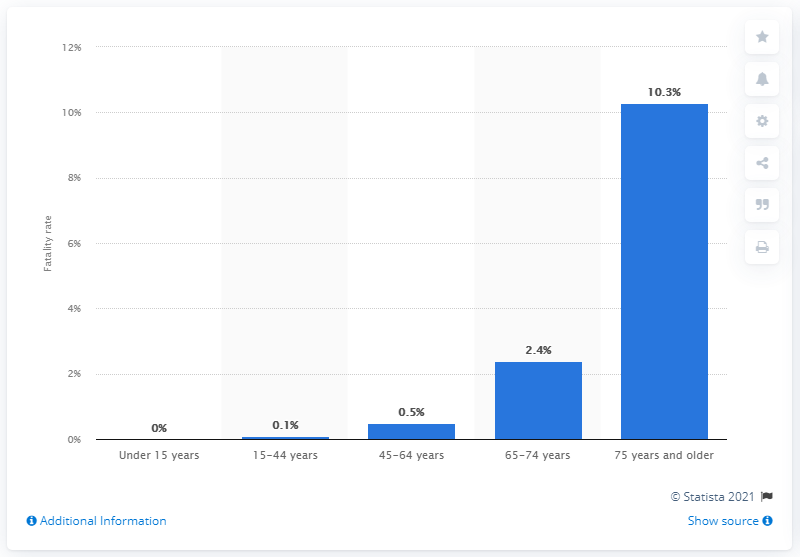Draw attention to some important aspects in this diagram. As of February 15, 2020, the fatality rate of patients aged 75 and older was 10.3%. 